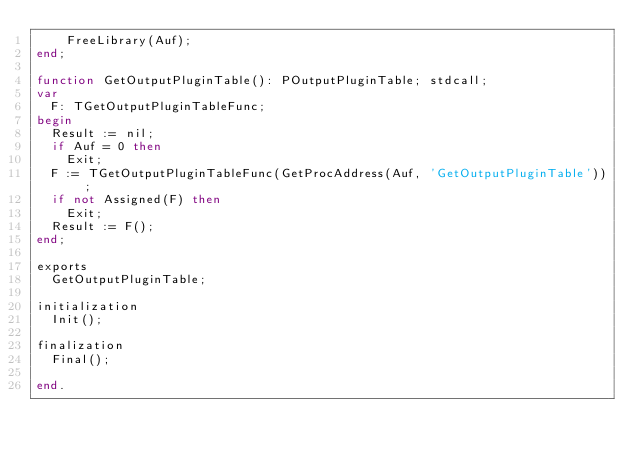Convert code to text. <code><loc_0><loc_0><loc_500><loc_500><_Pascal_>    FreeLibrary(Auf);
end;

function GetOutputPluginTable(): POutputPluginTable; stdcall;
var
  F: TGetOutputPluginTableFunc;
begin
  Result := nil;
  if Auf = 0 then
    Exit;
  F := TGetOutputPluginTableFunc(GetProcAddress(Auf, 'GetOutputPluginTable'));
  if not Assigned(F) then
    Exit;
  Result := F();
end;

exports
  GetOutputPluginTable;

initialization
  Init();

finalization
  Final();

end.

</code> 